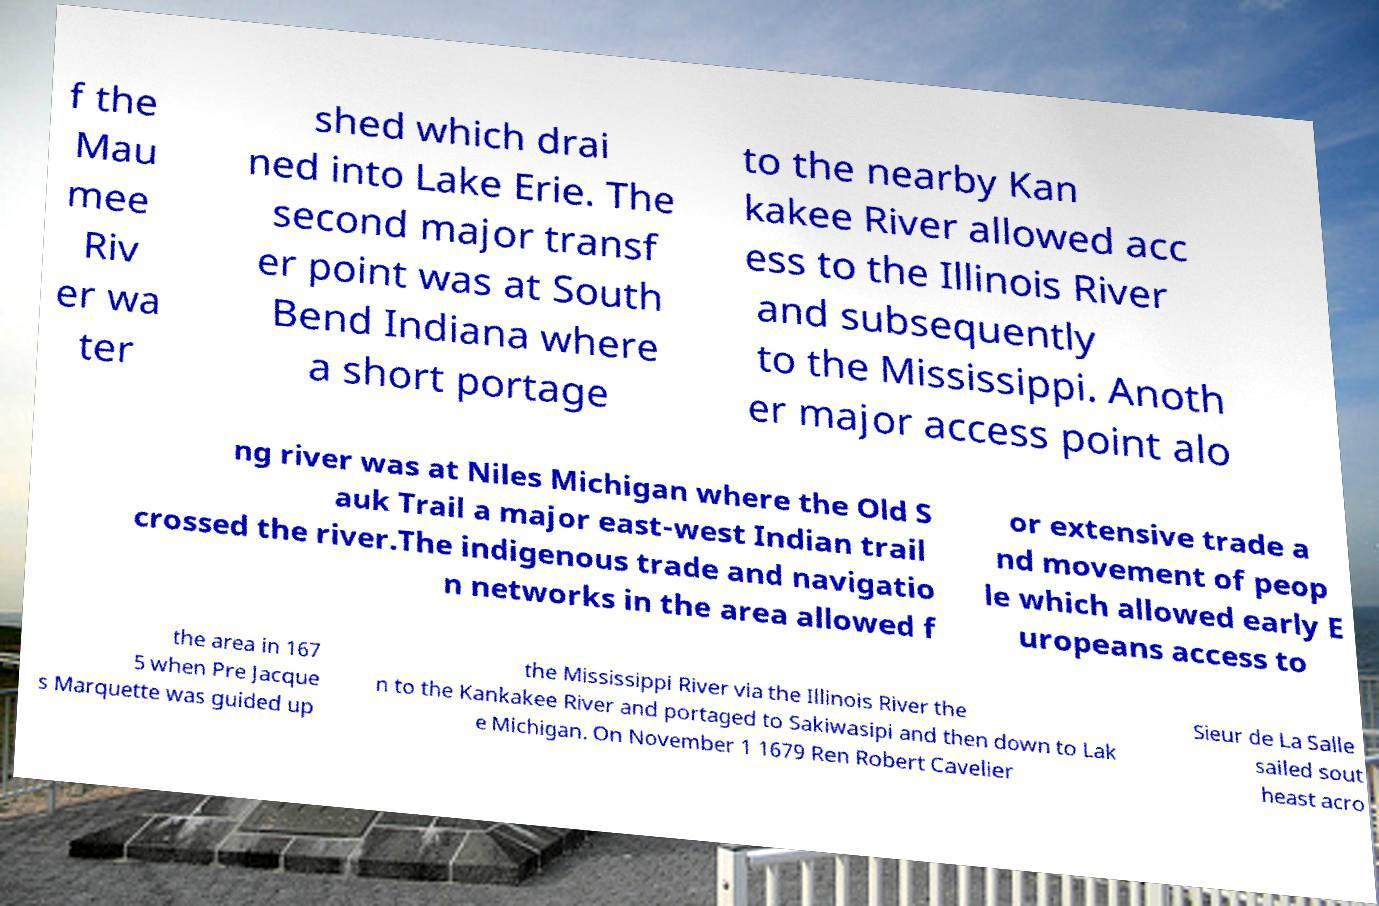For documentation purposes, I need the text within this image transcribed. Could you provide that? f the Mau mee Riv er wa ter shed which drai ned into Lake Erie. The second major transf er point was at South Bend Indiana where a short portage to the nearby Kan kakee River allowed acc ess to the Illinois River and subsequently to the Mississippi. Anoth er major access point alo ng river was at Niles Michigan where the Old S auk Trail a major east-west Indian trail crossed the river.The indigenous trade and navigatio n networks in the area allowed f or extensive trade a nd movement of peop le which allowed early E uropeans access to the area in 167 5 when Pre Jacque s Marquette was guided up the Mississippi River via the Illinois River the n to the Kankakee River and portaged to Sakiwasipi and then down to Lak e Michigan. On November 1 1679 Ren Robert Cavelier Sieur de La Salle sailed sout heast acro 